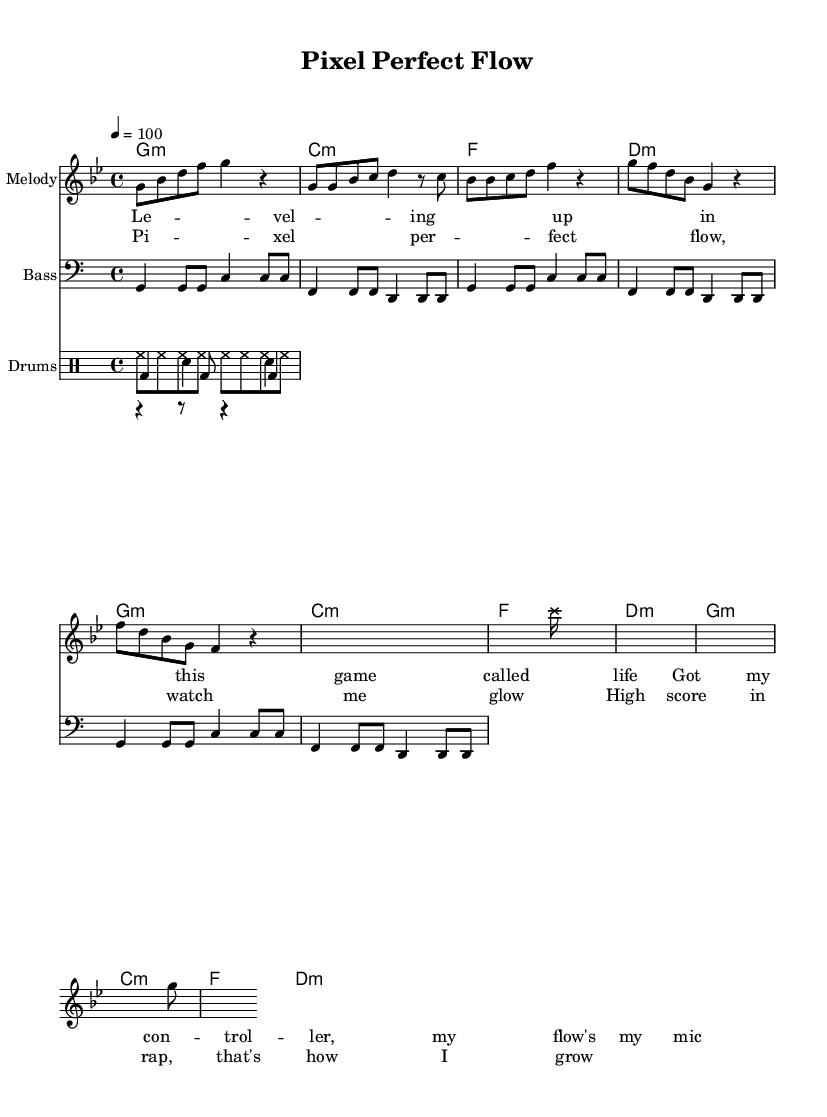What is the key signature of this music? The key signature is G minor, which has two flats (B flat and E flat). This can be determined by looking at the key signature that appears at the beginning of the sheet music.
Answer: G minor What is the time signature of this song? The time signature is 4/4, which is indicated at the beginning of the score. This means there are four beats in each measure, and the quarter note gets one beat.
Answer: 4/4 What is the tempo marking for the piece? The tempo marking is 100 BPM, which is indicated at the start of the score. This specifies that the piece should be played at a speed of 100 beats per minute.
Answer: 100 How many sections are in the structure of the music? The music consists of three main sections: Intro, Verse, and Chorus. Each section is identified through distinct patterns in the melody and lyrics, as laid out in the score.
Answer: Three What type of drum pattern is used for the kick drum? The kick drum pattern consists of quarter notes followed by an eighth note pattern, as represented in the `kickDrum` section of the score. This creates a driving force typical in upbeat hip-hop tracks.
Answer: Quarter and eighth notes What effect is indicated in the music, referring to video game sounds? The music includes glissando effects with `s2. \xNote c'''16` notation, which mimics game sound effects. This is specifically included to emulate elements from video games throughout the track.
Answer: Glissando sound effects What is the primary theme expressed in the chorus lyrics? The primary theme in the chorus revolves around achieving high scores and personal growth in rap, indicated by phrases like "Pixel perfect flow" and "High score in rap." The lyrics reflect a gaming-inspired metaphor for success.
Answer: High scores and growth 